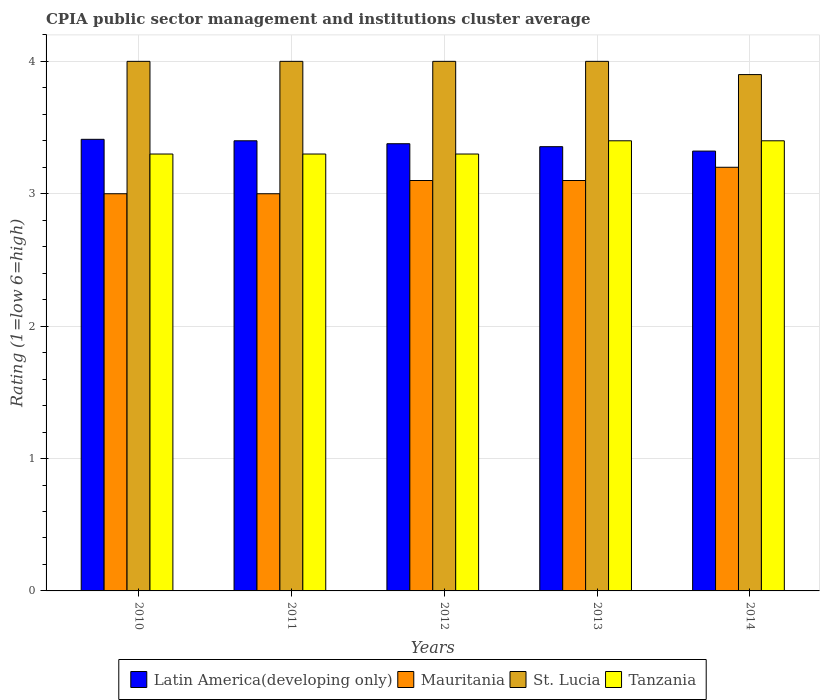How many different coloured bars are there?
Provide a succinct answer. 4. How many groups of bars are there?
Give a very brief answer. 5. What is the label of the 3rd group of bars from the left?
Offer a very short reply. 2012. In how many cases, is the number of bars for a given year not equal to the number of legend labels?
Make the answer very short. 0. Across all years, what is the minimum CPIA rating in Mauritania?
Your response must be concise. 3. In which year was the CPIA rating in St. Lucia minimum?
Your answer should be very brief. 2014. What is the difference between the CPIA rating in Latin America(developing only) in 2012 and that in 2013?
Provide a short and direct response. 0.02. What is the difference between the CPIA rating in Tanzania in 2010 and the CPIA rating in Latin America(developing only) in 2013?
Keep it short and to the point. -0.06. What is the average CPIA rating in St. Lucia per year?
Give a very brief answer. 3.98. In the year 2010, what is the difference between the CPIA rating in St. Lucia and CPIA rating in Latin America(developing only)?
Offer a terse response. 0.59. What is the ratio of the CPIA rating in St. Lucia in 2010 to that in 2011?
Give a very brief answer. 1. Is the CPIA rating in Latin America(developing only) in 2011 less than that in 2013?
Make the answer very short. No. What is the difference between the highest and the second highest CPIA rating in Mauritania?
Your answer should be very brief. 0.1. What is the difference between the highest and the lowest CPIA rating in Tanzania?
Give a very brief answer. 0.1. Is the sum of the CPIA rating in Latin America(developing only) in 2010 and 2013 greater than the maximum CPIA rating in St. Lucia across all years?
Give a very brief answer. Yes. What does the 3rd bar from the left in 2011 represents?
Ensure brevity in your answer.  St. Lucia. What does the 3rd bar from the right in 2013 represents?
Offer a terse response. Mauritania. How many bars are there?
Offer a terse response. 20. How many years are there in the graph?
Your answer should be compact. 5. What is the difference between two consecutive major ticks on the Y-axis?
Keep it short and to the point. 1. Does the graph contain any zero values?
Your answer should be compact. No. Does the graph contain grids?
Offer a very short reply. Yes. Where does the legend appear in the graph?
Provide a succinct answer. Bottom center. How are the legend labels stacked?
Offer a terse response. Horizontal. What is the title of the graph?
Your answer should be compact. CPIA public sector management and institutions cluster average. Does "Bermuda" appear as one of the legend labels in the graph?
Your answer should be compact. No. What is the Rating (1=low 6=high) of Latin America(developing only) in 2010?
Make the answer very short. 3.41. What is the Rating (1=low 6=high) of St. Lucia in 2010?
Keep it short and to the point. 4. What is the Rating (1=low 6=high) of Tanzania in 2010?
Ensure brevity in your answer.  3.3. What is the Rating (1=low 6=high) in Mauritania in 2011?
Provide a succinct answer. 3. What is the Rating (1=low 6=high) of Latin America(developing only) in 2012?
Give a very brief answer. 3.38. What is the Rating (1=low 6=high) of Mauritania in 2012?
Your response must be concise. 3.1. What is the Rating (1=low 6=high) of Tanzania in 2012?
Ensure brevity in your answer.  3.3. What is the Rating (1=low 6=high) of Latin America(developing only) in 2013?
Offer a very short reply. 3.36. What is the Rating (1=low 6=high) in Tanzania in 2013?
Your answer should be compact. 3.4. What is the Rating (1=low 6=high) in Latin America(developing only) in 2014?
Provide a short and direct response. 3.32. What is the Rating (1=low 6=high) in Mauritania in 2014?
Offer a terse response. 3.2. What is the Rating (1=low 6=high) in Tanzania in 2014?
Ensure brevity in your answer.  3.4. Across all years, what is the maximum Rating (1=low 6=high) of Latin America(developing only)?
Keep it short and to the point. 3.41. Across all years, what is the maximum Rating (1=low 6=high) of St. Lucia?
Keep it short and to the point. 4. Across all years, what is the maximum Rating (1=low 6=high) of Tanzania?
Your answer should be compact. 3.4. Across all years, what is the minimum Rating (1=low 6=high) of Latin America(developing only)?
Make the answer very short. 3.32. Across all years, what is the minimum Rating (1=low 6=high) of St. Lucia?
Keep it short and to the point. 3.9. Across all years, what is the minimum Rating (1=low 6=high) of Tanzania?
Keep it short and to the point. 3.3. What is the total Rating (1=low 6=high) in Latin America(developing only) in the graph?
Provide a succinct answer. 16.87. What is the total Rating (1=low 6=high) of Mauritania in the graph?
Offer a terse response. 15.4. What is the total Rating (1=low 6=high) of Tanzania in the graph?
Make the answer very short. 16.7. What is the difference between the Rating (1=low 6=high) in Latin America(developing only) in 2010 and that in 2011?
Make the answer very short. 0.01. What is the difference between the Rating (1=low 6=high) in Mauritania in 2010 and that in 2011?
Your answer should be very brief. 0. What is the difference between the Rating (1=low 6=high) of St. Lucia in 2010 and that in 2011?
Provide a succinct answer. 0. What is the difference between the Rating (1=low 6=high) of Tanzania in 2010 and that in 2011?
Make the answer very short. 0. What is the difference between the Rating (1=low 6=high) of Latin America(developing only) in 2010 and that in 2012?
Your response must be concise. 0.03. What is the difference between the Rating (1=low 6=high) in Mauritania in 2010 and that in 2012?
Your answer should be very brief. -0.1. What is the difference between the Rating (1=low 6=high) of St. Lucia in 2010 and that in 2012?
Your answer should be very brief. 0. What is the difference between the Rating (1=low 6=high) of Latin America(developing only) in 2010 and that in 2013?
Your answer should be very brief. 0.06. What is the difference between the Rating (1=low 6=high) of Mauritania in 2010 and that in 2013?
Provide a succinct answer. -0.1. What is the difference between the Rating (1=low 6=high) of St. Lucia in 2010 and that in 2013?
Your answer should be very brief. 0. What is the difference between the Rating (1=low 6=high) of Tanzania in 2010 and that in 2013?
Provide a succinct answer. -0.1. What is the difference between the Rating (1=low 6=high) of Latin America(developing only) in 2010 and that in 2014?
Make the answer very short. 0.09. What is the difference between the Rating (1=low 6=high) of Mauritania in 2010 and that in 2014?
Keep it short and to the point. -0.2. What is the difference between the Rating (1=low 6=high) in St. Lucia in 2010 and that in 2014?
Keep it short and to the point. 0.1. What is the difference between the Rating (1=low 6=high) in Tanzania in 2010 and that in 2014?
Provide a short and direct response. -0.1. What is the difference between the Rating (1=low 6=high) in Latin America(developing only) in 2011 and that in 2012?
Give a very brief answer. 0.02. What is the difference between the Rating (1=low 6=high) in Mauritania in 2011 and that in 2012?
Make the answer very short. -0.1. What is the difference between the Rating (1=low 6=high) of St. Lucia in 2011 and that in 2012?
Your answer should be very brief. 0. What is the difference between the Rating (1=low 6=high) of Latin America(developing only) in 2011 and that in 2013?
Give a very brief answer. 0.04. What is the difference between the Rating (1=low 6=high) in Tanzania in 2011 and that in 2013?
Provide a succinct answer. -0.1. What is the difference between the Rating (1=low 6=high) in Latin America(developing only) in 2011 and that in 2014?
Your answer should be very brief. 0.08. What is the difference between the Rating (1=low 6=high) of Latin America(developing only) in 2012 and that in 2013?
Your answer should be very brief. 0.02. What is the difference between the Rating (1=low 6=high) of St. Lucia in 2012 and that in 2013?
Make the answer very short. 0. What is the difference between the Rating (1=low 6=high) of Tanzania in 2012 and that in 2013?
Keep it short and to the point. -0.1. What is the difference between the Rating (1=low 6=high) in Latin America(developing only) in 2012 and that in 2014?
Ensure brevity in your answer.  0.06. What is the difference between the Rating (1=low 6=high) of Mauritania in 2012 and that in 2014?
Your response must be concise. -0.1. What is the difference between the Rating (1=low 6=high) in Latin America(developing only) in 2013 and that in 2014?
Ensure brevity in your answer.  0.03. What is the difference between the Rating (1=low 6=high) of St. Lucia in 2013 and that in 2014?
Keep it short and to the point. 0.1. What is the difference between the Rating (1=low 6=high) in Latin America(developing only) in 2010 and the Rating (1=low 6=high) in Mauritania in 2011?
Ensure brevity in your answer.  0.41. What is the difference between the Rating (1=low 6=high) of Latin America(developing only) in 2010 and the Rating (1=low 6=high) of St. Lucia in 2011?
Give a very brief answer. -0.59. What is the difference between the Rating (1=low 6=high) in Latin America(developing only) in 2010 and the Rating (1=low 6=high) in Tanzania in 2011?
Your response must be concise. 0.11. What is the difference between the Rating (1=low 6=high) of St. Lucia in 2010 and the Rating (1=low 6=high) of Tanzania in 2011?
Provide a short and direct response. 0.7. What is the difference between the Rating (1=low 6=high) of Latin America(developing only) in 2010 and the Rating (1=low 6=high) of Mauritania in 2012?
Your answer should be very brief. 0.31. What is the difference between the Rating (1=low 6=high) in Latin America(developing only) in 2010 and the Rating (1=low 6=high) in St. Lucia in 2012?
Provide a short and direct response. -0.59. What is the difference between the Rating (1=low 6=high) of Latin America(developing only) in 2010 and the Rating (1=low 6=high) of Tanzania in 2012?
Your response must be concise. 0.11. What is the difference between the Rating (1=low 6=high) in Mauritania in 2010 and the Rating (1=low 6=high) in Tanzania in 2012?
Keep it short and to the point. -0.3. What is the difference between the Rating (1=low 6=high) in Latin America(developing only) in 2010 and the Rating (1=low 6=high) in Mauritania in 2013?
Provide a short and direct response. 0.31. What is the difference between the Rating (1=low 6=high) of Latin America(developing only) in 2010 and the Rating (1=low 6=high) of St. Lucia in 2013?
Give a very brief answer. -0.59. What is the difference between the Rating (1=low 6=high) of Latin America(developing only) in 2010 and the Rating (1=low 6=high) of Tanzania in 2013?
Offer a terse response. 0.01. What is the difference between the Rating (1=low 6=high) of Mauritania in 2010 and the Rating (1=low 6=high) of Tanzania in 2013?
Ensure brevity in your answer.  -0.4. What is the difference between the Rating (1=low 6=high) of St. Lucia in 2010 and the Rating (1=low 6=high) of Tanzania in 2013?
Offer a very short reply. 0.6. What is the difference between the Rating (1=low 6=high) in Latin America(developing only) in 2010 and the Rating (1=low 6=high) in Mauritania in 2014?
Make the answer very short. 0.21. What is the difference between the Rating (1=low 6=high) of Latin America(developing only) in 2010 and the Rating (1=low 6=high) of St. Lucia in 2014?
Your answer should be compact. -0.49. What is the difference between the Rating (1=low 6=high) of Latin America(developing only) in 2010 and the Rating (1=low 6=high) of Tanzania in 2014?
Ensure brevity in your answer.  0.01. What is the difference between the Rating (1=low 6=high) of St. Lucia in 2010 and the Rating (1=low 6=high) of Tanzania in 2014?
Your answer should be compact. 0.6. What is the difference between the Rating (1=low 6=high) of Latin America(developing only) in 2011 and the Rating (1=low 6=high) of Mauritania in 2012?
Your answer should be compact. 0.3. What is the difference between the Rating (1=low 6=high) in Latin America(developing only) in 2011 and the Rating (1=low 6=high) in St. Lucia in 2012?
Provide a succinct answer. -0.6. What is the difference between the Rating (1=low 6=high) of Mauritania in 2011 and the Rating (1=low 6=high) of St. Lucia in 2012?
Make the answer very short. -1. What is the difference between the Rating (1=low 6=high) in Mauritania in 2011 and the Rating (1=low 6=high) in Tanzania in 2012?
Provide a succinct answer. -0.3. What is the difference between the Rating (1=low 6=high) in Latin America(developing only) in 2011 and the Rating (1=low 6=high) in Mauritania in 2013?
Provide a short and direct response. 0.3. What is the difference between the Rating (1=low 6=high) in Latin America(developing only) in 2011 and the Rating (1=low 6=high) in Tanzania in 2013?
Make the answer very short. 0. What is the difference between the Rating (1=low 6=high) of Mauritania in 2011 and the Rating (1=low 6=high) of Tanzania in 2013?
Offer a very short reply. -0.4. What is the difference between the Rating (1=low 6=high) of Latin America(developing only) in 2011 and the Rating (1=low 6=high) of St. Lucia in 2014?
Offer a very short reply. -0.5. What is the difference between the Rating (1=low 6=high) in Latin America(developing only) in 2011 and the Rating (1=low 6=high) in Tanzania in 2014?
Make the answer very short. 0. What is the difference between the Rating (1=low 6=high) of Mauritania in 2011 and the Rating (1=low 6=high) of St. Lucia in 2014?
Offer a terse response. -0.9. What is the difference between the Rating (1=low 6=high) in Mauritania in 2011 and the Rating (1=low 6=high) in Tanzania in 2014?
Offer a very short reply. -0.4. What is the difference between the Rating (1=low 6=high) in Latin America(developing only) in 2012 and the Rating (1=low 6=high) in Mauritania in 2013?
Give a very brief answer. 0.28. What is the difference between the Rating (1=low 6=high) of Latin America(developing only) in 2012 and the Rating (1=low 6=high) of St. Lucia in 2013?
Ensure brevity in your answer.  -0.62. What is the difference between the Rating (1=low 6=high) of Latin America(developing only) in 2012 and the Rating (1=low 6=high) of Tanzania in 2013?
Your answer should be compact. -0.02. What is the difference between the Rating (1=low 6=high) in St. Lucia in 2012 and the Rating (1=low 6=high) in Tanzania in 2013?
Offer a very short reply. 0.6. What is the difference between the Rating (1=low 6=high) of Latin America(developing only) in 2012 and the Rating (1=low 6=high) of Mauritania in 2014?
Your response must be concise. 0.18. What is the difference between the Rating (1=low 6=high) of Latin America(developing only) in 2012 and the Rating (1=low 6=high) of St. Lucia in 2014?
Provide a succinct answer. -0.52. What is the difference between the Rating (1=low 6=high) of Latin America(developing only) in 2012 and the Rating (1=low 6=high) of Tanzania in 2014?
Your answer should be very brief. -0.02. What is the difference between the Rating (1=low 6=high) of Mauritania in 2012 and the Rating (1=low 6=high) of St. Lucia in 2014?
Give a very brief answer. -0.8. What is the difference between the Rating (1=low 6=high) of Latin America(developing only) in 2013 and the Rating (1=low 6=high) of Mauritania in 2014?
Keep it short and to the point. 0.16. What is the difference between the Rating (1=low 6=high) of Latin America(developing only) in 2013 and the Rating (1=low 6=high) of St. Lucia in 2014?
Your response must be concise. -0.54. What is the difference between the Rating (1=low 6=high) of Latin America(developing only) in 2013 and the Rating (1=low 6=high) of Tanzania in 2014?
Your response must be concise. -0.04. What is the difference between the Rating (1=low 6=high) in Mauritania in 2013 and the Rating (1=low 6=high) in St. Lucia in 2014?
Offer a terse response. -0.8. What is the average Rating (1=low 6=high) in Latin America(developing only) per year?
Provide a short and direct response. 3.37. What is the average Rating (1=low 6=high) in Mauritania per year?
Offer a very short reply. 3.08. What is the average Rating (1=low 6=high) of St. Lucia per year?
Your response must be concise. 3.98. What is the average Rating (1=low 6=high) of Tanzania per year?
Ensure brevity in your answer.  3.34. In the year 2010, what is the difference between the Rating (1=low 6=high) of Latin America(developing only) and Rating (1=low 6=high) of Mauritania?
Keep it short and to the point. 0.41. In the year 2010, what is the difference between the Rating (1=low 6=high) of Latin America(developing only) and Rating (1=low 6=high) of St. Lucia?
Give a very brief answer. -0.59. In the year 2010, what is the difference between the Rating (1=low 6=high) of Latin America(developing only) and Rating (1=low 6=high) of Tanzania?
Provide a succinct answer. 0.11. In the year 2010, what is the difference between the Rating (1=low 6=high) in Mauritania and Rating (1=low 6=high) in St. Lucia?
Offer a very short reply. -1. In the year 2010, what is the difference between the Rating (1=low 6=high) in Mauritania and Rating (1=low 6=high) in Tanzania?
Your answer should be very brief. -0.3. In the year 2011, what is the difference between the Rating (1=low 6=high) in Latin America(developing only) and Rating (1=low 6=high) in Mauritania?
Make the answer very short. 0.4. In the year 2011, what is the difference between the Rating (1=low 6=high) of Latin America(developing only) and Rating (1=low 6=high) of St. Lucia?
Your answer should be compact. -0.6. In the year 2011, what is the difference between the Rating (1=low 6=high) of Latin America(developing only) and Rating (1=low 6=high) of Tanzania?
Keep it short and to the point. 0.1. In the year 2011, what is the difference between the Rating (1=low 6=high) in Mauritania and Rating (1=low 6=high) in St. Lucia?
Ensure brevity in your answer.  -1. In the year 2012, what is the difference between the Rating (1=low 6=high) of Latin America(developing only) and Rating (1=low 6=high) of Mauritania?
Provide a short and direct response. 0.28. In the year 2012, what is the difference between the Rating (1=low 6=high) in Latin America(developing only) and Rating (1=low 6=high) in St. Lucia?
Your answer should be compact. -0.62. In the year 2012, what is the difference between the Rating (1=low 6=high) of Latin America(developing only) and Rating (1=low 6=high) of Tanzania?
Your response must be concise. 0.08. In the year 2012, what is the difference between the Rating (1=low 6=high) of Mauritania and Rating (1=low 6=high) of St. Lucia?
Keep it short and to the point. -0.9. In the year 2012, what is the difference between the Rating (1=low 6=high) in Mauritania and Rating (1=low 6=high) in Tanzania?
Offer a terse response. -0.2. In the year 2012, what is the difference between the Rating (1=low 6=high) in St. Lucia and Rating (1=low 6=high) in Tanzania?
Provide a succinct answer. 0.7. In the year 2013, what is the difference between the Rating (1=low 6=high) of Latin America(developing only) and Rating (1=low 6=high) of Mauritania?
Provide a succinct answer. 0.26. In the year 2013, what is the difference between the Rating (1=low 6=high) of Latin America(developing only) and Rating (1=low 6=high) of St. Lucia?
Give a very brief answer. -0.64. In the year 2013, what is the difference between the Rating (1=low 6=high) of Latin America(developing only) and Rating (1=low 6=high) of Tanzania?
Keep it short and to the point. -0.04. In the year 2013, what is the difference between the Rating (1=low 6=high) of Mauritania and Rating (1=low 6=high) of St. Lucia?
Your answer should be compact. -0.9. In the year 2013, what is the difference between the Rating (1=low 6=high) in Mauritania and Rating (1=low 6=high) in Tanzania?
Your answer should be compact. -0.3. In the year 2014, what is the difference between the Rating (1=low 6=high) of Latin America(developing only) and Rating (1=low 6=high) of Mauritania?
Give a very brief answer. 0.12. In the year 2014, what is the difference between the Rating (1=low 6=high) of Latin America(developing only) and Rating (1=low 6=high) of St. Lucia?
Provide a succinct answer. -0.58. In the year 2014, what is the difference between the Rating (1=low 6=high) in Latin America(developing only) and Rating (1=low 6=high) in Tanzania?
Your answer should be compact. -0.08. What is the ratio of the Rating (1=low 6=high) of Latin America(developing only) in 2010 to that in 2011?
Offer a terse response. 1. What is the ratio of the Rating (1=low 6=high) in Mauritania in 2010 to that in 2011?
Make the answer very short. 1. What is the ratio of the Rating (1=low 6=high) of Tanzania in 2010 to that in 2011?
Your answer should be compact. 1. What is the ratio of the Rating (1=low 6=high) of Latin America(developing only) in 2010 to that in 2012?
Ensure brevity in your answer.  1.01. What is the ratio of the Rating (1=low 6=high) of St. Lucia in 2010 to that in 2012?
Provide a succinct answer. 1. What is the ratio of the Rating (1=low 6=high) of Latin America(developing only) in 2010 to that in 2013?
Provide a succinct answer. 1.02. What is the ratio of the Rating (1=low 6=high) in St. Lucia in 2010 to that in 2013?
Offer a terse response. 1. What is the ratio of the Rating (1=low 6=high) of Tanzania in 2010 to that in 2013?
Your answer should be compact. 0.97. What is the ratio of the Rating (1=low 6=high) in Latin America(developing only) in 2010 to that in 2014?
Offer a very short reply. 1.03. What is the ratio of the Rating (1=low 6=high) of St. Lucia in 2010 to that in 2014?
Your answer should be compact. 1.03. What is the ratio of the Rating (1=low 6=high) in Tanzania in 2010 to that in 2014?
Your response must be concise. 0.97. What is the ratio of the Rating (1=low 6=high) in Latin America(developing only) in 2011 to that in 2012?
Keep it short and to the point. 1.01. What is the ratio of the Rating (1=low 6=high) of Mauritania in 2011 to that in 2012?
Provide a succinct answer. 0.97. What is the ratio of the Rating (1=low 6=high) of Tanzania in 2011 to that in 2012?
Provide a short and direct response. 1. What is the ratio of the Rating (1=low 6=high) in Latin America(developing only) in 2011 to that in 2013?
Keep it short and to the point. 1.01. What is the ratio of the Rating (1=low 6=high) of St. Lucia in 2011 to that in 2013?
Your answer should be very brief. 1. What is the ratio of the Rating (1=low 6=high) of Tanzania in 2011 to that in 2013?
Keep it short and to the point. 0.97. What is the ratio of the Rating (1=low 6=high) in Latin America(developing only) in 2011 to that in 2014?
Keep it short and to the point. 1.02. What is the ratio of the Rating (1=low 6=high) of St. Lucia in 2011 to that in 2014?
Make the answer very short. 1.03. What is the ratio of the Rating (1=low 6=high) of Tanzania in 2011 to that in 2014?
Provide a succinct answer. 0.97. What is the ratio of the Rating (1=low 6=high) of Latin America(developing only) in 2012 to that in 2013?
Provide a succinct answer. 1.01. What is the ratio of the Rating (1=low 6=high) in Mauritania in 2012 to that in 2013?
Give a very brief answer. 1. What is the ratio of the Rating (1=low 6=high) of St. Lucia in 2012 to that in 2013?
Ensure brevity in your answer.  1. What is the ratio of the Rating (1=low 6=high) in Tanzania in 2012 to that in 2013?
Make the answer very short. 0.97. What is the ratio of the Rating (1=low 6=high) of Latin America(developing only) in 2012 to that in 2014?
Your response must be concise. 1.02. What is the ratio of the Rating (1=low 6=high) of Mauritania in 2012 to that in 2014?
Offer a very short reply. 0.97. What is the ratio of the Rating (1=low 6=high) of St. Lucia in 2012 to that in 2014?
Offer a very short reply. 1.03. What is the ratio of the Rating (1=low 6=high) of Tanzania in 2012 to that in 2014?
Provide a short and direct response. 0.97. What is the ratio of the Rating (1=low 6=high) in Latin America(developing only) in 2013 to that in 2014?
Your response must be concise. 1.01. What is the ratio of the Rating (1=low 6=high) of Mauritania in 2013 to that in 2014?
Your answer should be compact. 0.97. What is the ratio of the Rating (1=low 6=high) in St. Lucia in 2013 to that in 2014?
Your answer should be very brief. 1.03. What is the ratio of the Rating (1=low 6=high) of Tanzania in 2013 to that in 2014?
Offer a terse response. 1. What is the difference between the highest and the second highest Rating (1=low 6=high) in Latin America(developing only)?
Keep it short and to the point. 0.01. What is the difference between the highest and the second highest Rating (1=low 6=high) of Mauritania?
Provide a succinct answer. 0.1. What is the difference between the highest and the second highest Rating (1=low 6=high) of St. Lucia?
Provide a short and direct response. 0. What is the difference between the highest and the second highest Rating (1=low 6=high) of Tanzania?
Give a very brief answer. 0. What is the difference between the highest and the lowest Rating (1=low 6=high) in Latin America(developing only)?
Provide a succinct answer. 0.09. 